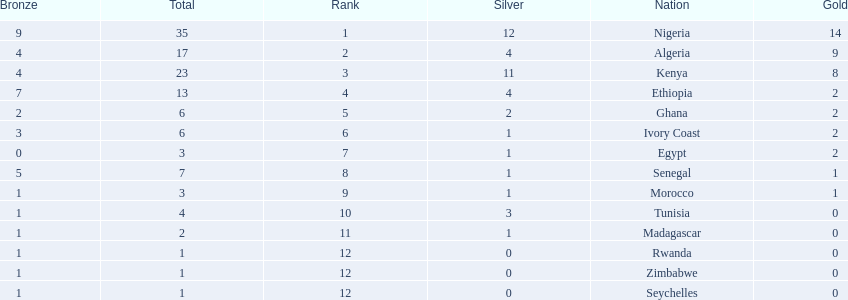How many silver medals did kenya earn? 11. 